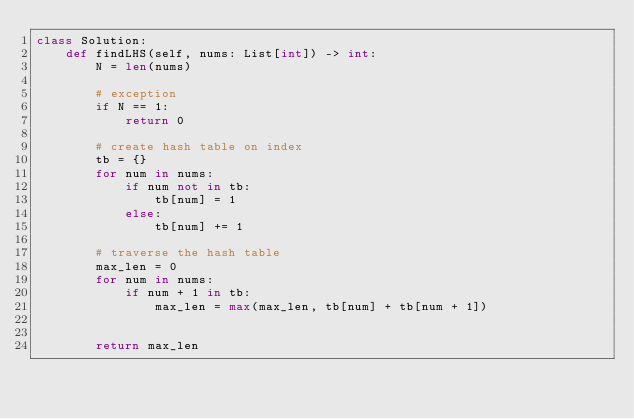<code> <loc_0><loc_0><loc_500><loc_500><_Python_>class Solution:
    def findLHS(self, nums: List[int]) -> int:
        N = len(nums)
        
        # exception
        if N == 1:
            return 0
        
        # create hash table on index
        tb = {}
        for num in nums:
            if num not in tb:
                tb[num] = 1
            else:
                tb[num] += 1
        
        # traverse the hash table
        max_len = 0
        for num in nums:
            if num + 1 in tb:
                max_len = max(max_len, tb[num] + tb[num + 1])
                
                
        return max_len
                    
                
                </code> 